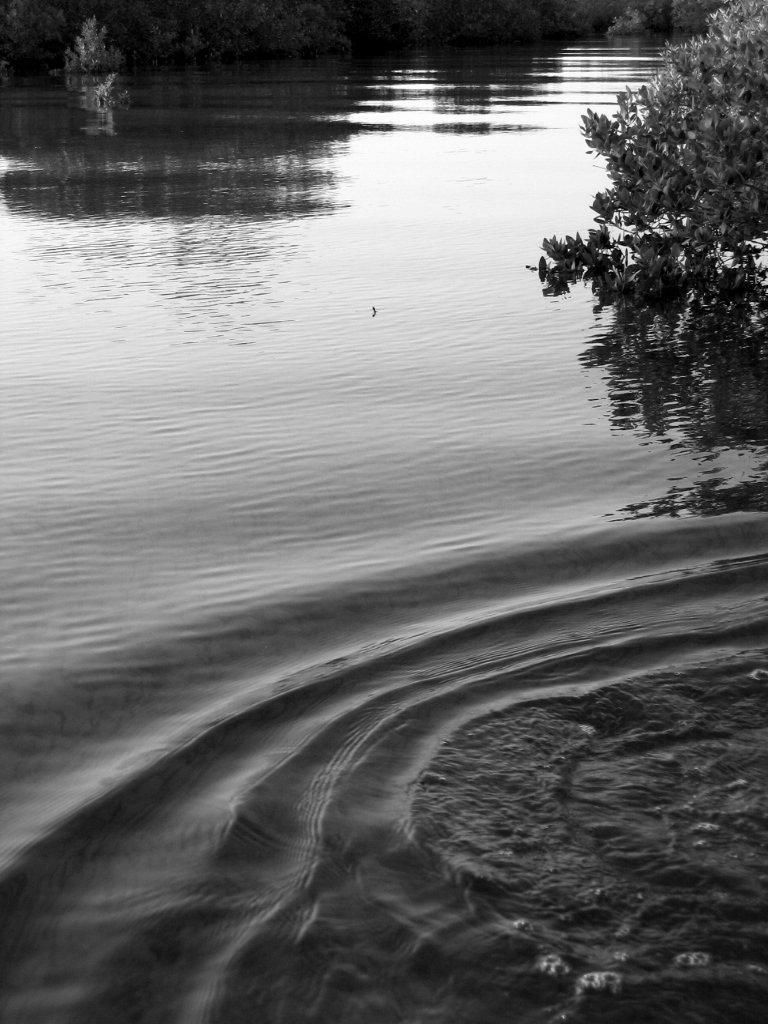Describe this image in one or two sentences. In this picture there is water around the area of the image and there are plants at the top side of the image. 